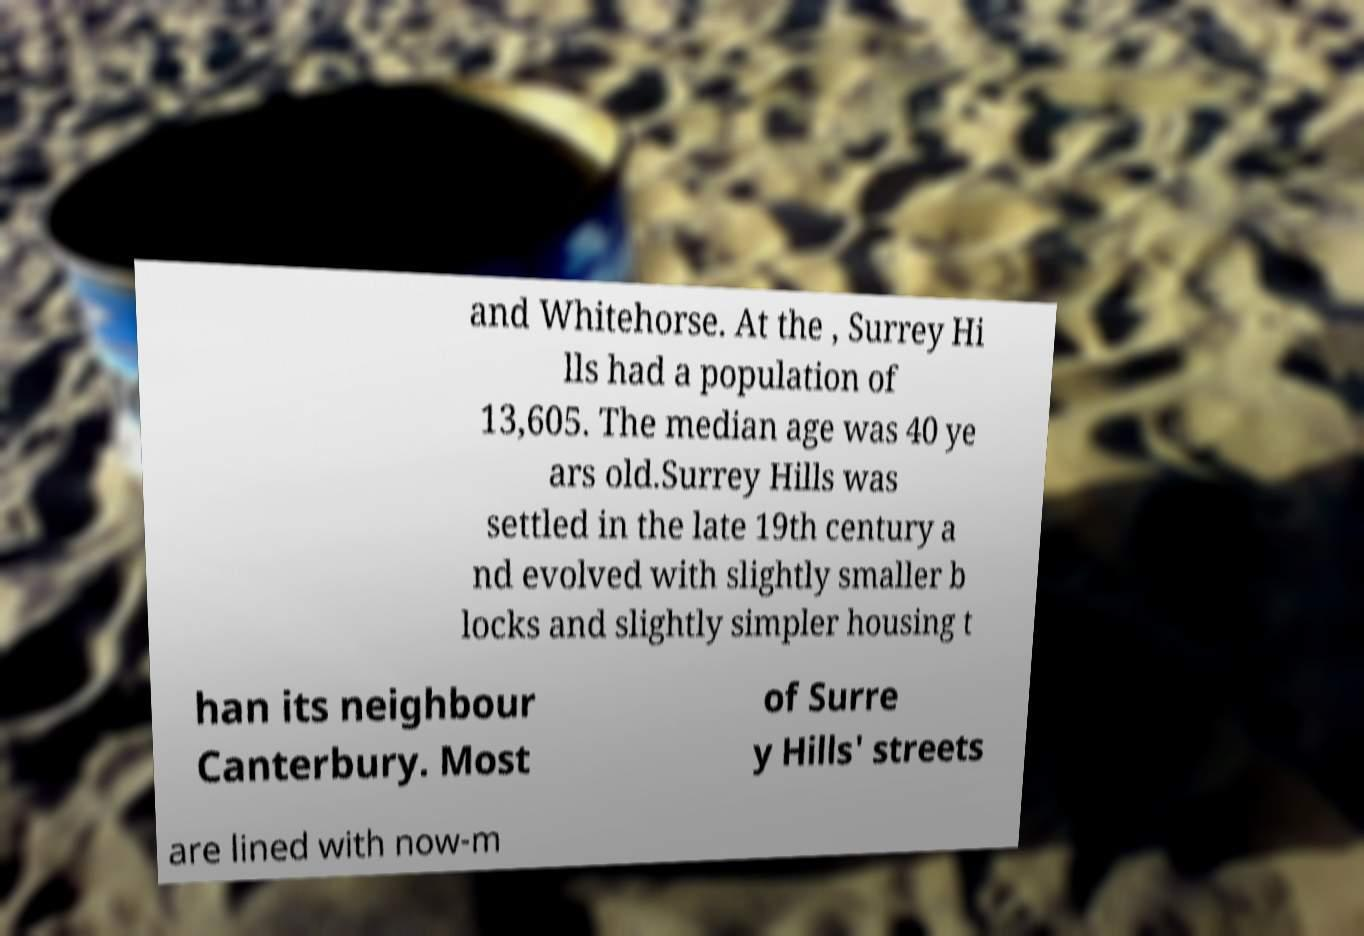I need the written content from this picture converted into text. Can you do that? and Whitehorse. At the , Surrey Hi lls had a population of 13,605. The median age was 40 ye ars old.Surrey Hills was settled in the late 19th century a nd evolved with slightly smaller b locks and slightly simpler housing t han its neighbour Canterbury. Most of Surre y Hills' streets are lined with now-m 